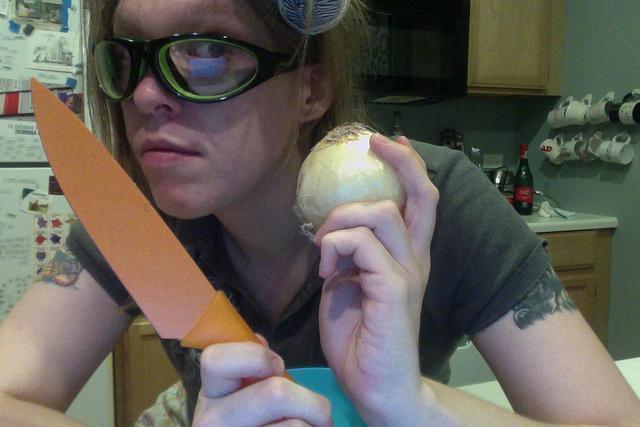How many people are there?
Give a very brief answer. 1. How many statues on the clock have wings?
Give a very brief answer. 0. 